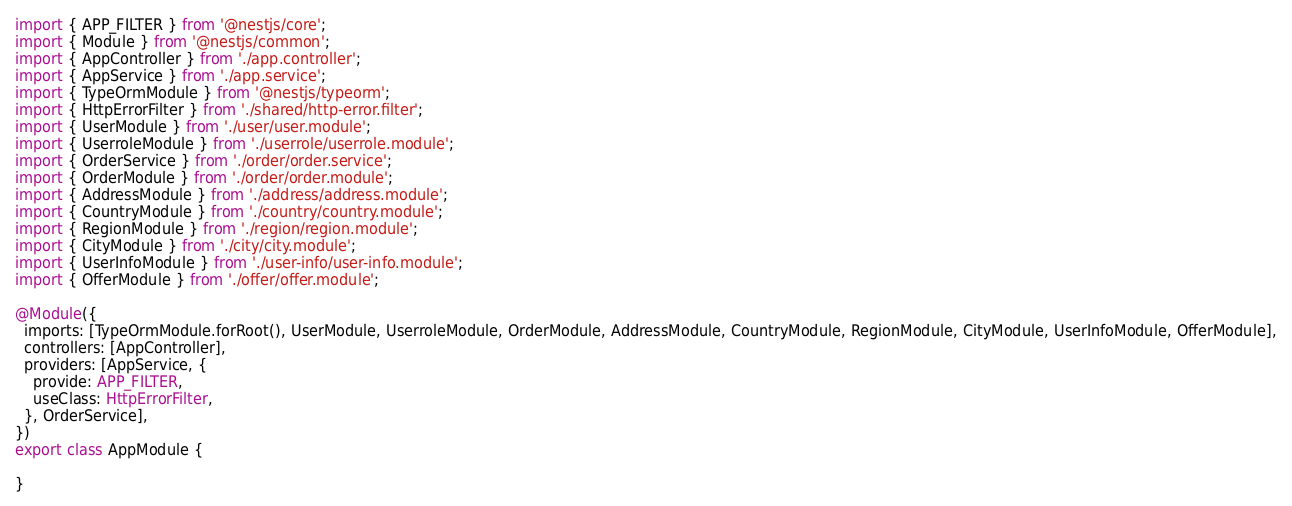Convert code to text. <code><loc_0><loc_0><loc_500><loc_500><_TypeScript_>import { APP_FILTER } from '@nestjs/core';
import { Module } from '@nestjs/common';
import { AppController } from './app.controller';
import { AppService } from './app.service';
import { TypeOrmModule } from '@nestjs/typeorm';
import { HttpErrorFilter } from './shared/http-error.filter';
import { UserModule } from './user/user.module';
import { UserroleModule } from './userrole/userrole.module';
import { OrderService } from './order/order.service';
import { OrderModule } from './order/order.module';
import { AddressModule } from './address/address.module';
import { CountryModule } from './country/country.module';
import { RegionModule } from './region/region.module';
import { CityModule } from './city/city.module';
import { UserInfoModule } from './user-info/user-info.module';
import { OfferModule } from './offer/offer.module';

@Module({
  imports: [TypeOrmModule.forRoot(), UserModule, UserroleModule, OrderModule, AddressModule, CountryModule, RegionModule, CityModule, UserInfoModule, OfferModule],
  controllers: [AppController],
  providers: [AppService, {
    provide: APP_FILTER,
    useClass: HttpErrorFilter,
  }, OrderService],
})
export class AppModule {

}
</code> 